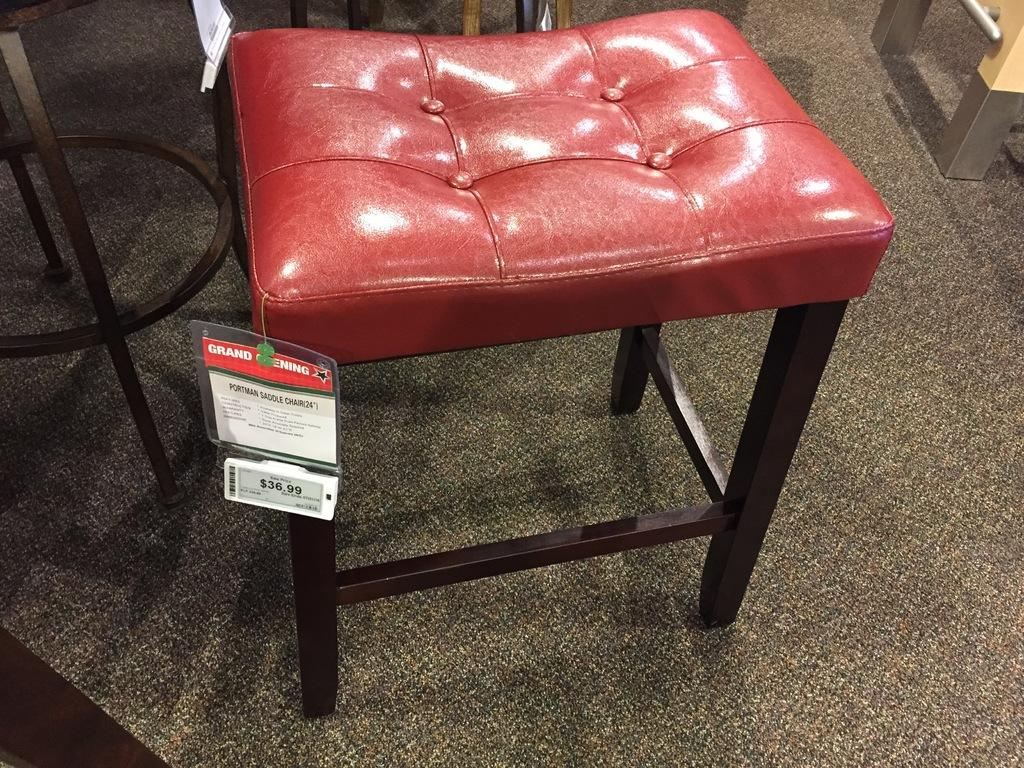What type of furniture is in the image? There is a stool in the image. Is there any additional information about the stool? Yes, there is a tag attached to the stool. What can be found on the tag? The tag has numbers and text on it. What type of flooring is visible in the image? There is carpet on the floor. What is located to the left of the stool? There are metal rods to the left of the stool. What type of chess piece is sitting on the stool in the image? There is no chess piece present in the image; it only features a stool with a tag and metal rods. How does the spoon interact with the jelly on the stool? There is no spoon or jelly present in the image; it only features a stool with a tag and metal rods. 